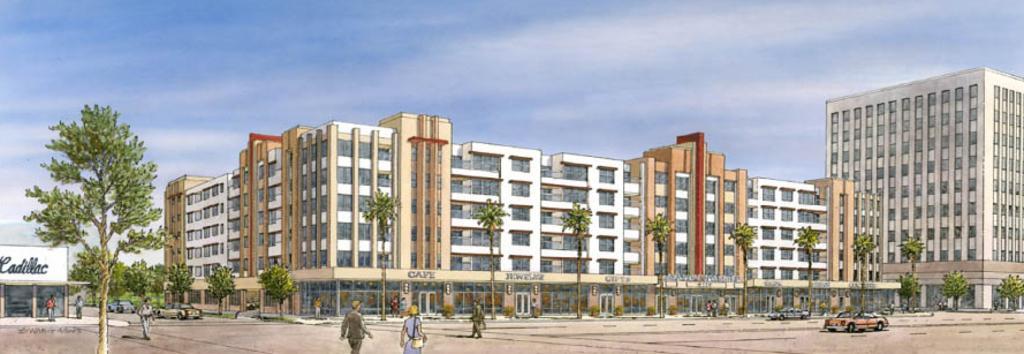How would you summarize this image in a sentence or two? In this image we can see the picture containing group of persons and group of vehicles. In the center we can see the buildings and trees. In the background we can see the sky. On the left corner we can see the text on the building. 